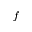Convert formula to latex. <formula><loc_0><loc_0><loc_500><loc_500>\bar { f }</formula> 